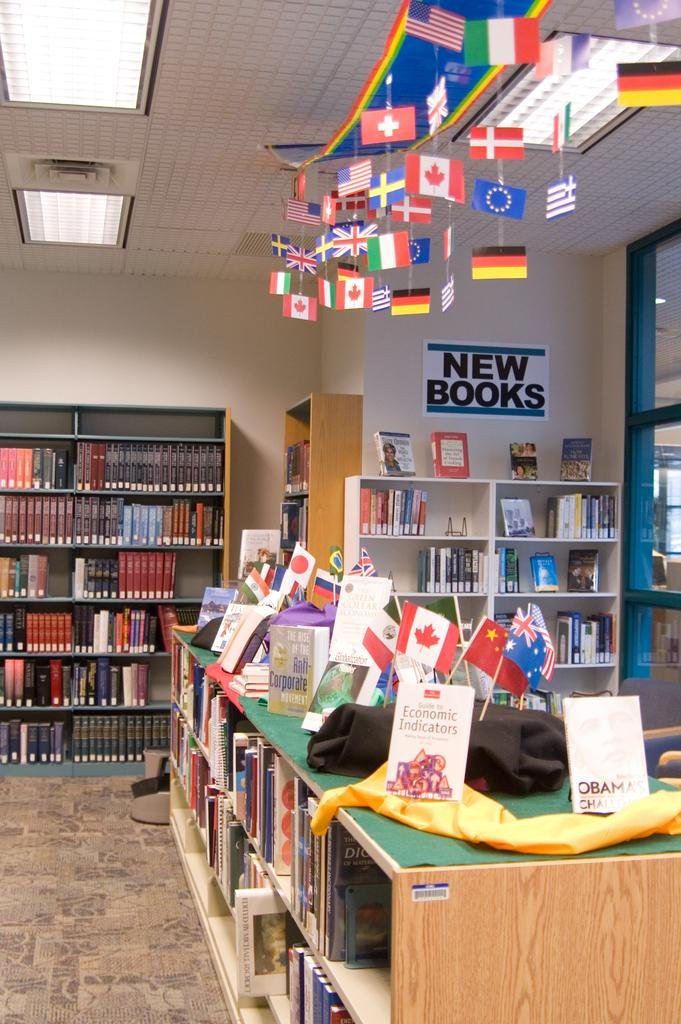<image>
Relay a brief, clear account of the picture shown. A library with lots of books and a sign letting you know there are new books. 